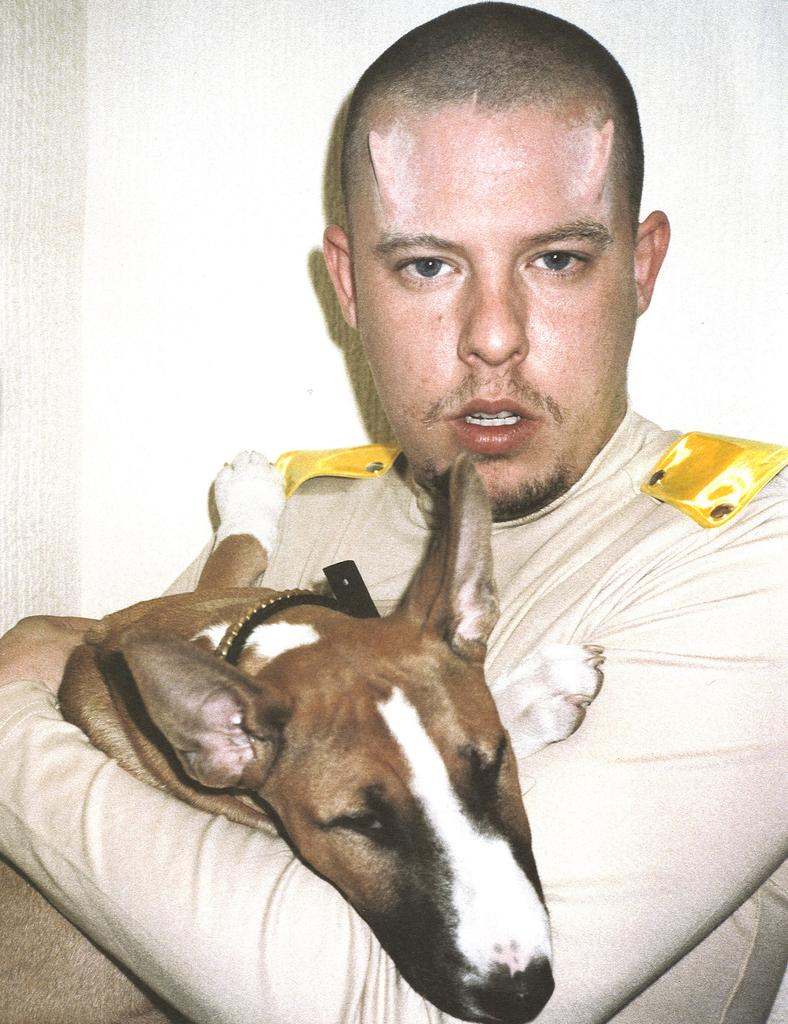What is the main subject of the image? There is a person in the image. Where is the person located in the image? The person is standing at the center of the image. What is the person holding in his hands? The person is holding a dog in his hands. What distinguishing feature can be seen on the person's forehead? There are horns on the forehead of the person. Can you tell me how many bats are flying around the person in the image? There are no bats present in the image; the person is holding a dog. Is there a lake visible in the background of the image? There is no lake visible in the image; the focus is on the person and the dog. 